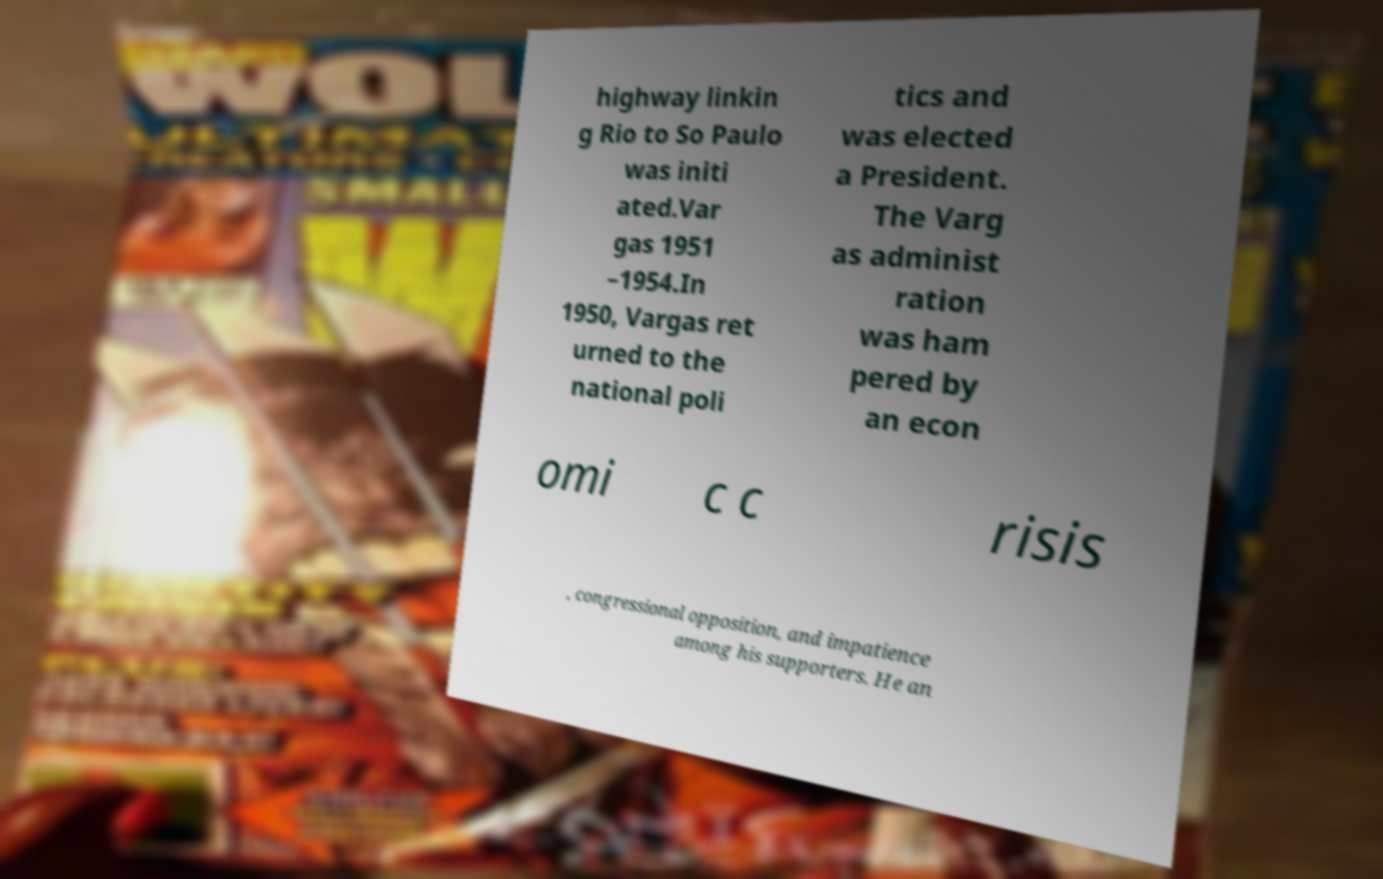Please read and relay the text visible in this image. What does it say? highway linkin g Rio to So Paulo was initi ated.Var gas 1951 –1954.In 1950, Vargas ret urned to the national poli tics and was elected a President. The Varg as administ ration was ham pered by an econ omi c c risis , congressional opposition, and impatience among his supporters. He an 